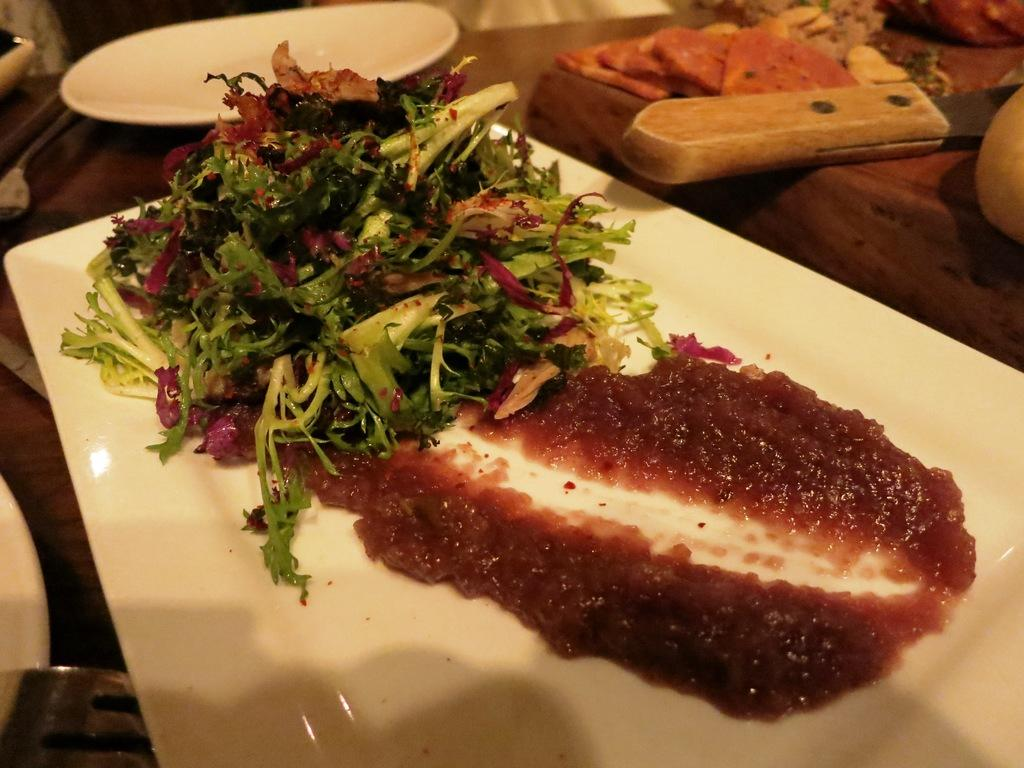What is contained in the tray that is visible in the image? There is food in a tray in the image. What other items can be seen on the table in the image? There are plates and bowls containing food on the table in the image. What utensil is present in the image? There is a knife in the image. What type of vest is being worn by the food in the image? There is no person or clothing item, including a vest, present in the image. The image only contains food, plates, bowls, and a knife. 